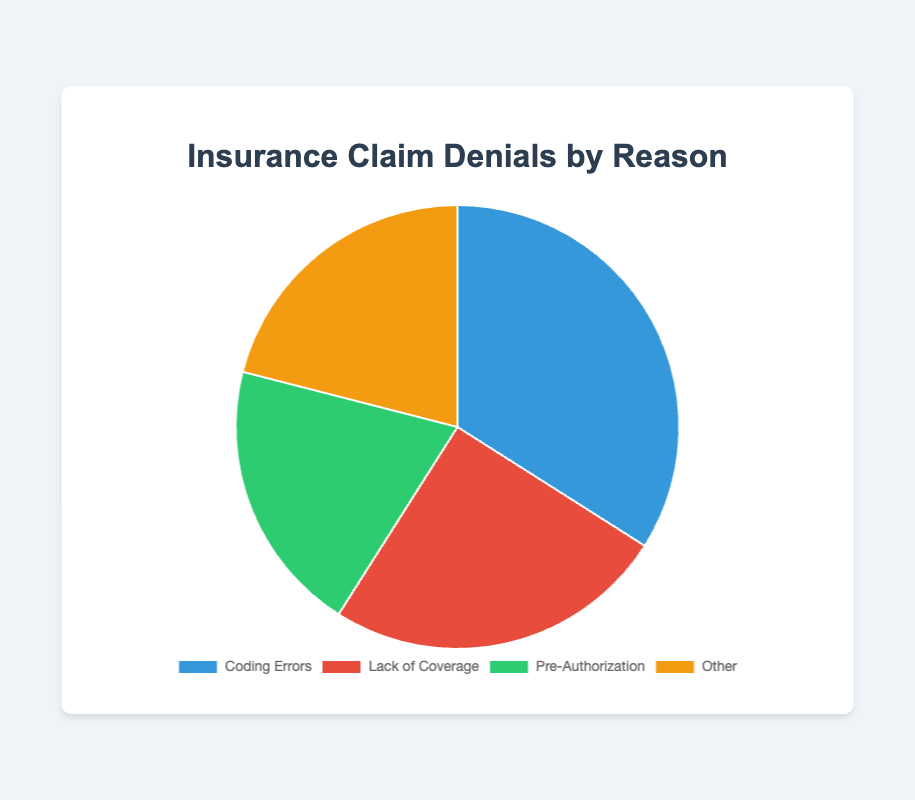What is the most common reason for insurance claim denials? By looking at the pie chart, we can see that "Coding Errors" has the highest percentage, which is 34%.
Answer: Coding Errors Which reason has the second highest percentage of insurance claim denials? The second largest segment in the pie chart corresponds to "Lack of Coverage" at 25%.
Answer: Lack of Coverage How do "Coding Errors" and "Lack of Coverage" compare in terms of their percentage contributions to claim denials? "Coding Errors" account for 34% and "Lack of Coverage" account for 25%. The difference between these two reasons is 34 - 25 = 9%.
Answer: Coding Errors are 9% more than Lack of Coverage What percentage of denials are due to reasons other than "Coding Errors"? The percentage of denials due to other reasons can be found by summing the percentages of all other reasons: Lack of Coverage (25%) + Pre-Authorization (20%) + Other (21%) = 66%.
Answer: 66% What is the least frequent reason for claim denials? The smallest segment of the pie chart is for "Pre-Authorization," which accounts for 20% of the denials.
Answer: Pre-Authorization How much higher is the percentage of "Coding Errors" compared to "Pre-Authorization"? "Coding Errors" account for 34% and "Pre-Authorization" account for 20%. The percentage difference is 34 - 20 = 14%.
Answer: 14% What is the combined percentage of denials due to "Coding Errors" and "Pre-Authorization"? Adding the percentages for "Coding Errors" and "Pre-Authorization" gives 34 + 20 = 54%.
Answer: 54% Which two reasons combined make up nearly half (approximately 50%) of all denials? "Lack of Coverage" and "Other" combined make 25% + 21% = 46%, which is nearly half of all denials.
Answer: Lack of Coverage and Other If you were to combine "Lack of Coverage" and "Pre-Authorization," what would be their total percentage of denials? Adding the percentages for "Lack of Coverage" (25%) and "Pre-Authorization" (20%) gives 25 + 20 = 45%.
Answer: 45% What color represents the "Other" category in the pie chart? By observing the pie chart, the color that represents "Other" is orange.
Answer: Orange 